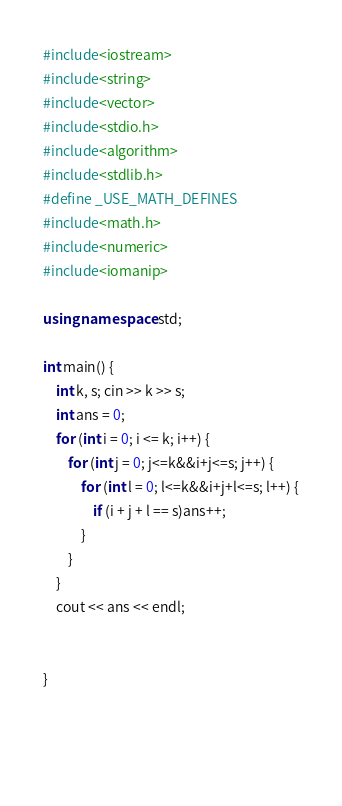<code> <loc_0><loc_0><loc_500><loc_500><_C++_>#include<iostream>
#include<string>
#include<vector>
#include<stdio.h>
#include<algorithm>
#include<stdlib.h>
#define _USE_MATH_DEFINES
#include<math.h>
#include<numeric>
#include<iomanip>

using namespace std;

int main() {
	int k, s; cin >> k >> s;
	int ans = 0;
	for (int i = 0; i <= k; i++) {
		for (int j = 0; j<=k&&i+j<=s; j++) {
			for (int l = 0; l<=k&&i+j+l<=s; l++) {
				if (i + j + l == s)ans++;
			}
		}
	}
	cout << ans << endl;
	

}


    </code> 